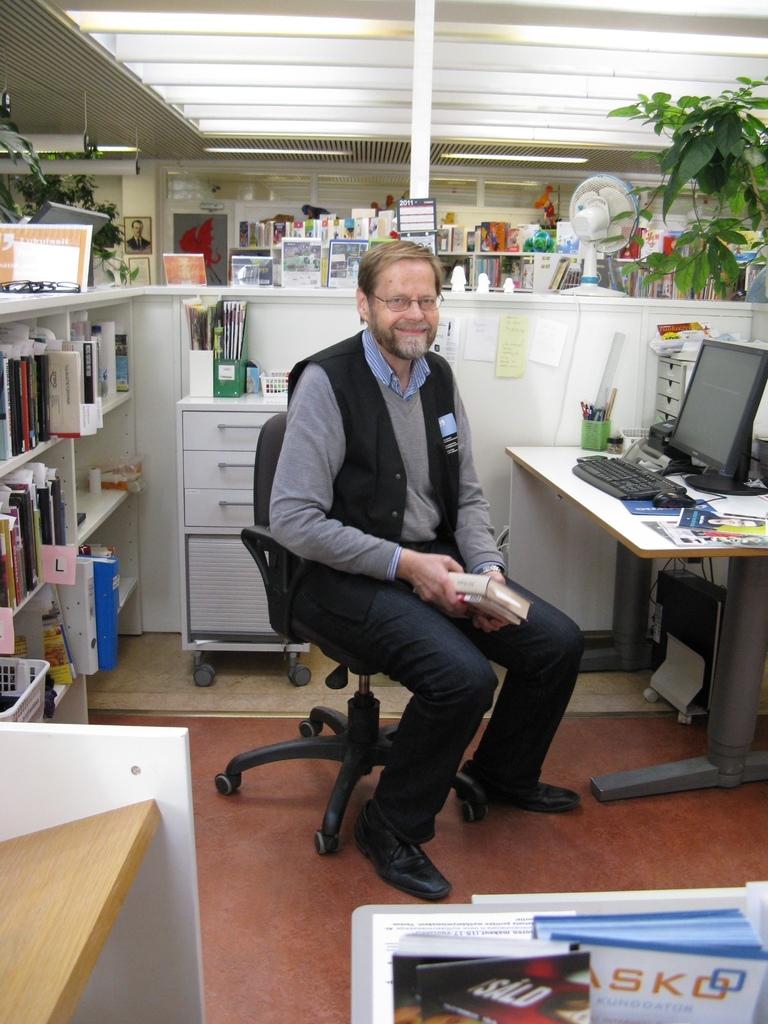What letter is on the small pink and white sign on the shelf?
Provide a short and direct response. Unanswerable. 